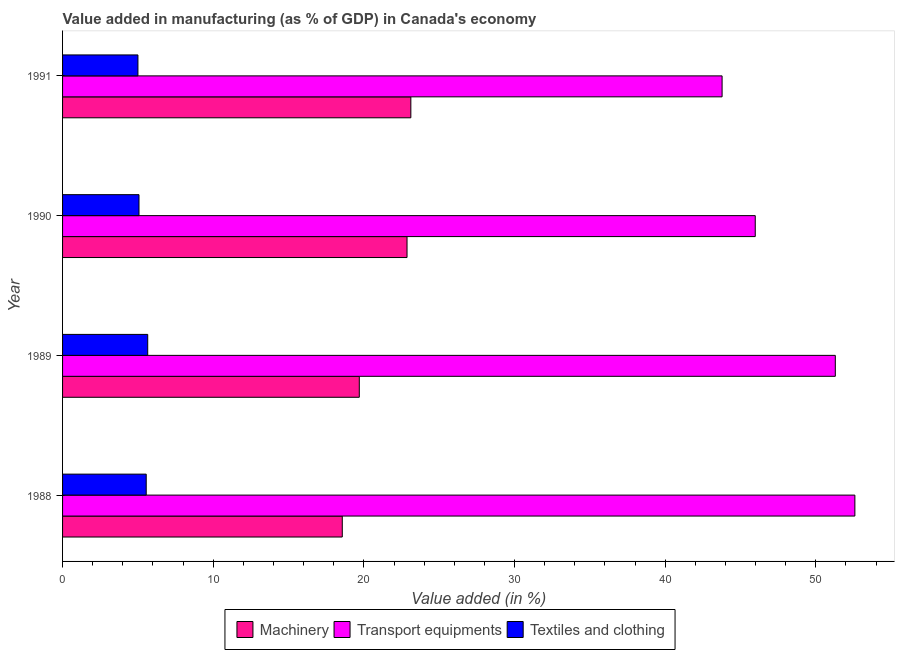Are the number of bars on each tick of the Y-axis equal?
Offer a very short reply. Yes. How many bars are there on the 4th tick from the top?
Your response must be concise. 3. How many bars are there on the 1st tick from the bottom?
Make the answer very short. 3. What is the label of the 1st group of bars from the top?
Provide a succinct answer. 1991. In how many cases, is the number of bars for a given year not equal to the number of legend labels?
Offer a very short reply. 0. What is the value added in manufacturing textile and clothing in 1991?
Your response must be concise. 5. Across all years, what is the maximum value added in manufacturing textile and clothing?
Your response must be concise. 5.65. Across all years, what is the minimum value added in manufacturing machinery?
Provide a succinct answer. 18.57. What is the total value added in manufacturing machinery in the graph?
Ensure brevity in your answer.  84.25. What is the difference between the value added in manufacturing machinery in 1990 and that in 1991?
Keep it short and to the point. -0.25. What is the difference between the value added in manufacturing transport equipments in 1991 and the value added in manufacturing machinery in 1989?
Ensure brevity in your answer.  24.08. What is the average value added in manufacturing transport equipments per year?
Give a very brief answer. 48.41. In the year 1988, what is the difference between the value added in manufacturing transport equipments and value added in manufacturing machinery?
Provide a short and direct response. 34.02. What is the ratio of the value added in manufacturing machinery in 1988 to that in 1991?
Ensure brevity in your answer.  0.8. Is the value added in manufacturing textile and clothing in 1990 less than that in 1991?
Provide a succinct answer. No. Is the difference between the value added in manufacturing machinery in 1988 and 1989 greater than the difference between the value added in manufacturing transport equipments in 1988 and 1989?
Your response must be concise. No. What is the difference between the highest and the second highest value added in manufacturing machinery?
Ensure brevity in your answer.  0.25. What is the difference between the highest and the lowest value added in manufacturing transport equipments?
Give a very brief answer. 8.81. In how many years, is the value added in manufacturing machinery greater than the average value added in manufacturing machinery taken over all years?
Make the answer very short. 2. What does the 2nd bar from the top in 1989 represents?
Your response must be concise. Transport equipments. What does the 1st bar from the bottom in 1988 represents?
Offer a terse response. Machinery. What is the difference between two consecutive major ticks on the X-axis?
Offer a terse response. 10. Does the graph contain grids?
Offer a very short reply. No. What is the title of the graph?
Provide a succinct answer. Value added in manufacturing (as % of GDP) in Canada's economy. Does "Natural Gas" appear as one of the legend labels in the graph?
Your response must be concise. No. What is the label or title of the X-axis?
Provide a succinct answer. Value added (in %). What is the Value added (in %) in Machinery in 1988?
Make the answer very short. 18.57. What is the Value added (in %) of Transport equipments in 1988?
Provide a succinct answer. 52.59. What is the Value added (in %) of Textiles and clothing in 1988?
Your answer should be compact. 5.55. What is the Value added (in %) in Machinery in 1989?
Your response must be concise. 19.7. What is the Value added (in %) in Transport equipments in 1989?
Give a very brief answer. 51.29. What is the Value added (in %) in Textiles and clothing in 1989?
Your response must be concise. 5.65. What is the Value added (in %) of Machinery in 1990?
Provide a short and direct response. 22.86. What is the Value added (in %) in Transport equipments in 1990?
Your answer should be compact. 45.98. What is the Value added (in %) in Textiles and clothing in 1990?
Offer a terse response. 5.07. What is the Value added (in %) of Machinery in 1991?
Keep it short and to the point. 23.12. What is the Value added (in %) of Transport equipments in 1991?
Provide a succinct answer. 43.78. What is the Value added (in %) of Textiles and clothing in 1991?
Provide a succinct answer. 5. Across all years, what is the maximum Value added (in %) of Machinery?
Provide a short and direct response. 23.12. Across all years, what is the maximum Value added (in %) in Transport equipments?
Ensure brevity in your answer.  52.59. Across all years, what is the maximum Value added (in %) in Textiles and clothing?
Make the answer very short. 5.65. Across all years, what is the minimum Value added (in %) of Machinery?
Provide a short and direct response. 18.57. Across all years, what is the minimum Value added (in %) in Transport equipments?
Offer a terse response. 43.78. Across all years, what is the minimum Value added (in %) of Textiles and clothing?
Make the answer very short. 5. What is the total Value added (in %) of Machinery in the graph?
Offer a terse response. 84.25. What is the total Value added (in %) in Transport equipments in the graph?
Your response must be concise. 193.64. What is the total Value added (in %) in Textiles and clothing in the graph?
Your response must be concise. 21.28. What is the difference between the Value added (in %) in Machinery in 1988 and that in 1989?
Make the answer very short. -1.13. What is the difference between the Value added (in %) of Transport equipments in 1988 and that in 1989?
Give a very brief answer. 1.3. What is the difference between the Value added (in %) in Textiles and clothing in 1988 and that in 1989?
Your response must be concise. -0.1. What is the difference between the Value added (in %) of Machinery in 1988 and that in 1990?
Provide a short and direct response. -4.3. What is the difference between the Value added (in %) in Transport equipments in 1988 and that in 1990?
Ensure brevity in your answer.  6.61. What is the difference between the Value added (in %) in Textiles and clothing in 1988 and that in 1990?
Make the answer very short. 0.48. What is the difference between the Value added (in %) in Machinery in 1988 and that in 1991?
Give a very brief answer. -4.55. What is the difference between the Value added (in %) of Transport equipments in 1988 and that in 1991?
Keep it short and to the point. 8.81. What is the difference between the Value added (in %) in Textiles and clothing in 1988 and that in 1991?
Your answer should be compact. 0.55. What is the difference between the Value added (in %) in Machinery in 1989 and that in 1990?
Provide a succinct answer. -3.17. What is the difference between the Value added (in %) in Transport equipments in 1989 and that in 1990?
Your response must be concise. 5.31. What is the difference between the Value added (in %) in Textiles and clothing in 1989 and that in 1990?
Provide a succinct answer. 0.58. What is the difference between the Value added (in %) of Machinery in 1989 and that in 1991?
Provide a succinct answer. -3.42. What is the difference between the Value added (in %) in Transport equipments in 1989 and that in 1991?
Provide a short and direct response. 7.52. What is the difference between the Value added (in %) in Textiles and clothing in 1989 and that in 1991?
Offer a very short reply. 0.65. What is the difference between the Value added (in %) of Machinery in 1990 and that in 1991?
Your response must be concise. -0.25. What is the difference between the Value added (in %) of Transport equipments in 1990 and that in 1991?
Provide a short and direct response. 2.2. What is the difference between the Value added (in %) in Textiles and clothing in 1990 and that in 1991?
Ensure brevity in your answer.  0.07. What is the difference between the Value added (in %) of Machinery in 1988 and the Value added (in %) of Transport equipments in 1989?
Your answer should be very brief. -32.73. What is the difference between the Value added (in %) of Machinery in 1988 and the Value added (in %) of Textiles and clothing in 1989?
Your answer should be very brief. 12.91. What is the difference between the Value added (in %) of Transport equipments in 1988 and the Value added (in %) of Textiles and clothing in 1989?
Your answer should be very brief. 46.94. What is the difference between the Value added (in %) of Machinery in 1988 and the Value added (in %) of Transport equipments in 1990?
Keep it short and to the point. -27.41. What is the difference between the Value added (in %) of Machinery in 1988 and the Value added (in %) of Textiles and clothing in 1990?
Offer a terse response. 13.49. What is the difference between the Value added (in %) in Transport equipments in 1988 and the Value added (in %) in Textiles and clothing in 1990?
Offer a terse response. 47.52. What is the difference between the Value added (in %) in Machinery in 1988 and the Value added (in %) in Transport equipments in 1991?
Your answer should be compact. -25.21. What is the difference between the Value added (in %) in Machinery in 1988 and the Value added (in %) in Textiles and clothing in 1991?
Offer a very short reply. 13.56. What is the difference between the Value added (in %) in Transport equipments in 1988 and the Value added (in %) in Textiles and clothing in 1991?
Offer a terse response. 47.59. What is the difference between the Value added (in %) in Machinery in 1989 and the Value added (in %) in Transport equipments in 1990?
Ensure brevity in your answer.  -26.28. What is the difference between the Value added (in %) in Machinery in 1989 and the Value added (in %) in Textiles and clothing in 1990?
Your answer should be compact. 14.62. What is the difference between the Value added (in %) of Transport equipments in 1989 and the Value added (in %) of Textiles and clothing in 1990?
Your response must be concise. 46.22. What is the difference between the Value added (in %) of Machinery in 1989 and the Value added (in %) of Transport equipments in 1991?
Ensure brevity in your answer.  -24.08. What is the difference between the Value added (in %) of Machinery in 1989 and the Value added (in %) of Textiles and clothing in 1991?
Keep it short and to the point. 14.69. What is the difference between the Value added (in %) of Transport equipments in 1989 and the Value added (in %) of Textiles and clothing in 1991?
Offer a very short reply. 46.29. What is the difference between the Value added (in %) of Machinery in 1990 and the Value added (in %) of Transport equipments in 1991?
Your answer should be compact. -20.91. What is the difference between the Value added (in %) of Machinery in 1990 and the Value added (in %) of Textiles and clothing in 1991?
Your answer should be compact. 17.86. What is the difference between the Value added (in %) of Transport equipments in 1990 and the Value added (in %) of Textiles and clothing in 1991?
Offer a terse response. 40.98. What is the average Value added (in %) of Machinery per year?
Give a very brief answer. 21.06. What is the average Value added (in %) in Transport equipments per year?
Your answer should be very brief. 48.41. What is the average Value added (in %) of Textiles and clothing per year?
Your answer should be compact. 5.32. In the year 1988, what is the difference between the Value added (in %) of Machinery and Value added (in %) of Transport equipments?
Make the answer very short. -34.02. In the year 1988, what is the difference between the Value added (in %) in Machinery and Value added (in %) in Textiles and clothing?
Ensure brevity in your answer.  13.01. In the year 1988, what is the difference between the Value added (in %) of Transport equipments and Value added (in %) of Textiles and clothing?
Provide a succinct answer. 47.04. In the year 1989, what is the difference between the Value added (in %) of Machinery and Value added (in %) of Transport equipments?
Your response must be concise. -31.6. In the year 1989, what is the difference between the Value added (in %) of Machinery and Value added (in %) of Textiles and clothing?
Your answer should be compact. 14.04. In the year 1989, what is the difference between the Value added (in %) in Transport equipments and Value added (in %) in Textiles and clothing?
Give a very brief answer. 45.64. In the year 1990, what is the difference between the Value added (in %) in Machinery and Value added (in %) in Transport equipments?
Keep it short and to the point. -23.11. In the year 1990, what is the difference between the Value added (in %) of Machinery and Value added (in %) of Textiles and clothing?
Ensure brevity in your answer.  17.79. In the year 1990, what is the difference between the Value added (in %) in Transport equipments and Value added (in %) in Textiles and clothing?
Provide a short and direct response. 40.91. In the year 1991, what is the difference between the Value added (in %) in Machinery and Value added (in %) in Transport equipments?
Ensure brevity in your answer.  -20.66. In the year 1991, what is the difference between the Value added (in %) in Machinery and Value added (in %) in Textiles and clothing?
Your answer should be very brief. 18.11. In the year 1991, what is the difference between the Value added (in %) of Transport equipments and Value added (in %) of Textiles and clothing?
Provide a succinct answer. 38.77. What is the ratio of the Value added (in %) in Machinery in 1988 to that in 1989?
Keep it short and to the point. 0.94. What is the ratio of the Value added (in %) of Transport equipments in 1988 to that in 1989?
Provide a short and direct response. 1.03. What is the ratio of the Value added (in %) of Textiles and clothing in 1988 to that in 1989?
Provide a short and direct response. 0.98. What is the ratio of the Value added (in %) in Machinery in 1988 to that in 1990?
Provide a succinct answer. 0.81. What is the ratio of the Value added (in %) of Transport equipments in 1988 to that in 1990?
Give a very brief answer. 1.14. What is the ratio of the Value added (in %) of Textiles and clothing in 1988 to that in 1990?
Provide a succinct answer. 1.09. What is the ratio of the Value added (in %) in Machinery in 1988 to that in 1991?
Your answer should be very brief. 0.8. What is the ratio of the Value added (in %) of Transport equipments in 1988 to that in 1991?
Provide a short and direct response. 1.2. What is the ratio of the Value added (in %) of Textiles and clothing in 1988 to that in 1991?
Give a very brief answer. 1.11. What is the ratio of the Value added (in %) of Machinery in 1989 to that in 1990?
Make the answer very short. 0.86. What is the ratio of the Value added (in %) of Transport equipments in 1989 to that in 1990?
Provide a short and direct response. 1.12. What is the ratio of the Value added (in %) in Textiles and clothing in 1989 to that in 1990?
Offer a very short reply. 1.11. What is the ratio of the Value added (in %) of Machinery in 1989 to that in 1991?
Your answer should be very brief. 0.85. What is the ratio of the Value added (in %) of Transport equipments in 1989 to that in 1991?
Your answer should be very brief. 1.17. What is the ratio of the Value added (in %) in Textiles and clothing in 1989 to that in 1991?
Provide a succinct answer. 1.13. What is the ratio of the Value added (in %) of Transport equipments in 1990 to that in 1991?
Your answer should be very brief. 1.05. What is the difference between the highest and the second highest Value added (in %) in Machinery?
Give a very brief answer. 0.25. What is the difference between the highest and the second highest Value added (in %) in Transport equipments?
Offer a terse response. 1.3. What is the difference between the highest and the second highest Value added (in %) of Textiles and clothing?
Your answer should be very brief. 0.1. What is the difference between the highest and the lowest Value added (in %) in Machinery?
Give a very brief answer. 4.55. What is the difference between the highest and the lowest Value added (in %) of Transport equipments?
Your answer should be very brief. 8.81. What is the difference between the highest and the lowest Value added (in %) of Textiles and clothing?
Your answer should be very brief. 0.65. 